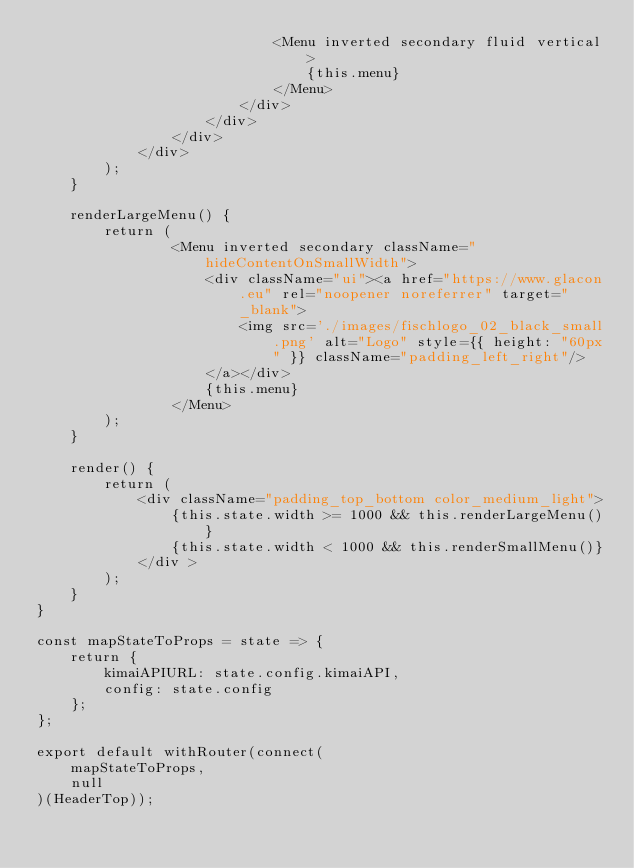Convert code to text. <code><loc_0><loc_0><loc_500><loc_500><_JavaScript_>                            <Menu inverted secondary fluid vertical>
                                {this.menu}
                            </Menu>
                        </div>
                    </div>
                </div>
            </div>
        );
    }

    renderLargeMenu() {
        return (            
                <Menu inverted secondary className="hideContentOnSmallWidth">
                    <div className="ui"><a href="https://www.glacon.eu" rel="noopener noreferrer" target="_blank">
                        <img src='./images/fischlogo_02_black_small.png' alt="Logo" style={{ height: "60px" }} className="padding_left_right"/>
                    </a></div>                    
                    {this.menu}
                </Menu>
        );
    }

    render() {
        return (
            <div className="padding_top_bottom color_medium_light">
                {this.state.width >= 1000 && this.renderLargeMenu()}
                {this.state.width < 1000 && this.renderSmallMenu()}
            </div >
        );
    }
}

const mapStateToProps = state => {
    return {
        kimaiAPIURL: state.config.kimaiAPI,
        config: state.config
    };
};

export default withRouter(connect(
    mapStateToProps,
    null
)(HeaderTop));
</code> 